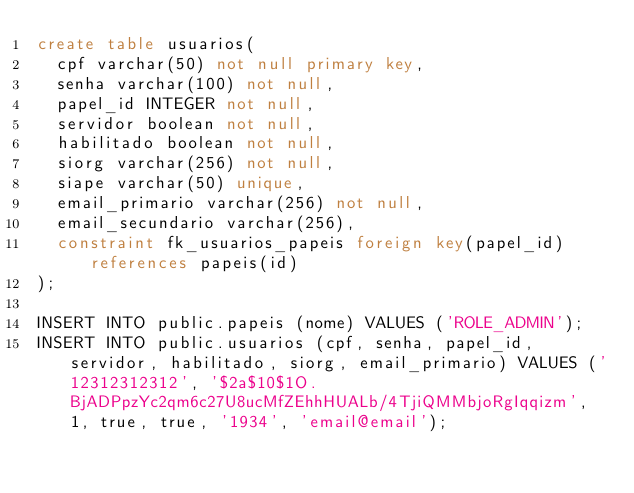<code> <loc_0><loc_0><loc_500><loc_500><_SQL_>create table usuarios(
  cpf varchar(50) not null primary key,
  senha varchar(100) not null,
  papel_id INTEGER not null,
  servidor boolean not null,
  habilitado boolean not null,
  siorg varchar(256) not null,
  siape varchar(50) unique,
  email_primario varchar(256) not null,
  email_secundario varchar(256),
  constraint fk_usuarios_papeis foreign key(papel_id) references papeis(id)
);

INSERT INTO public.papeis (nome) VALUES ('ROLE_ADMIN');
INSERT INTO public.usuarios (cpf, senha, papel_id, servidor, habilitado, siorg, email_primario) VALUES ('12312312312', '$2a$10$1O.BjADPpzYc2qm6c27U8ucMfZEhhHUALb/4TjiQMMbjoRgIqqizm', 1, true, true, '1934', 'email@email');
</code> 